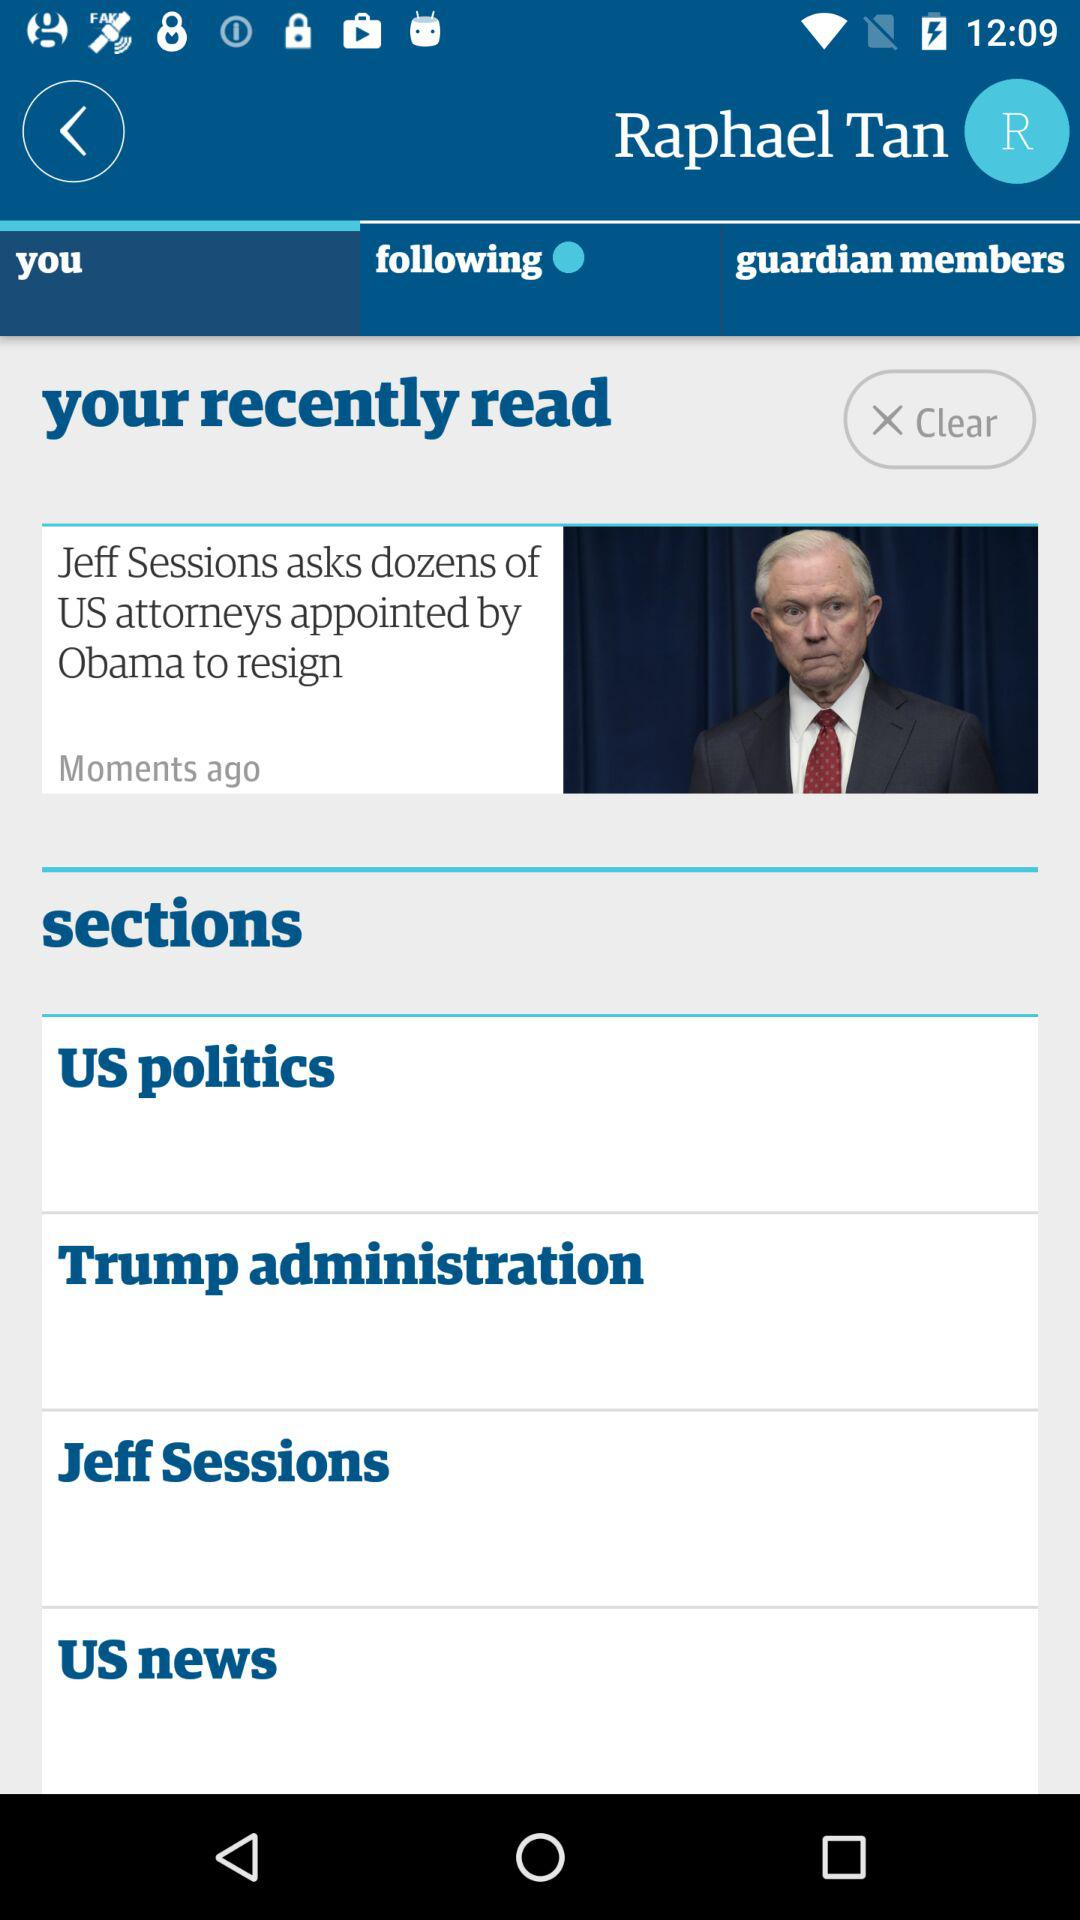Which tab is selected? The selected tab is "you". 